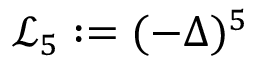<formula> <loc_0><loc_0><loc_500><loc_500>\mathcal { L } _ { 5 } \colon = ( - \Delta ) ^ { 5 }</formula> 